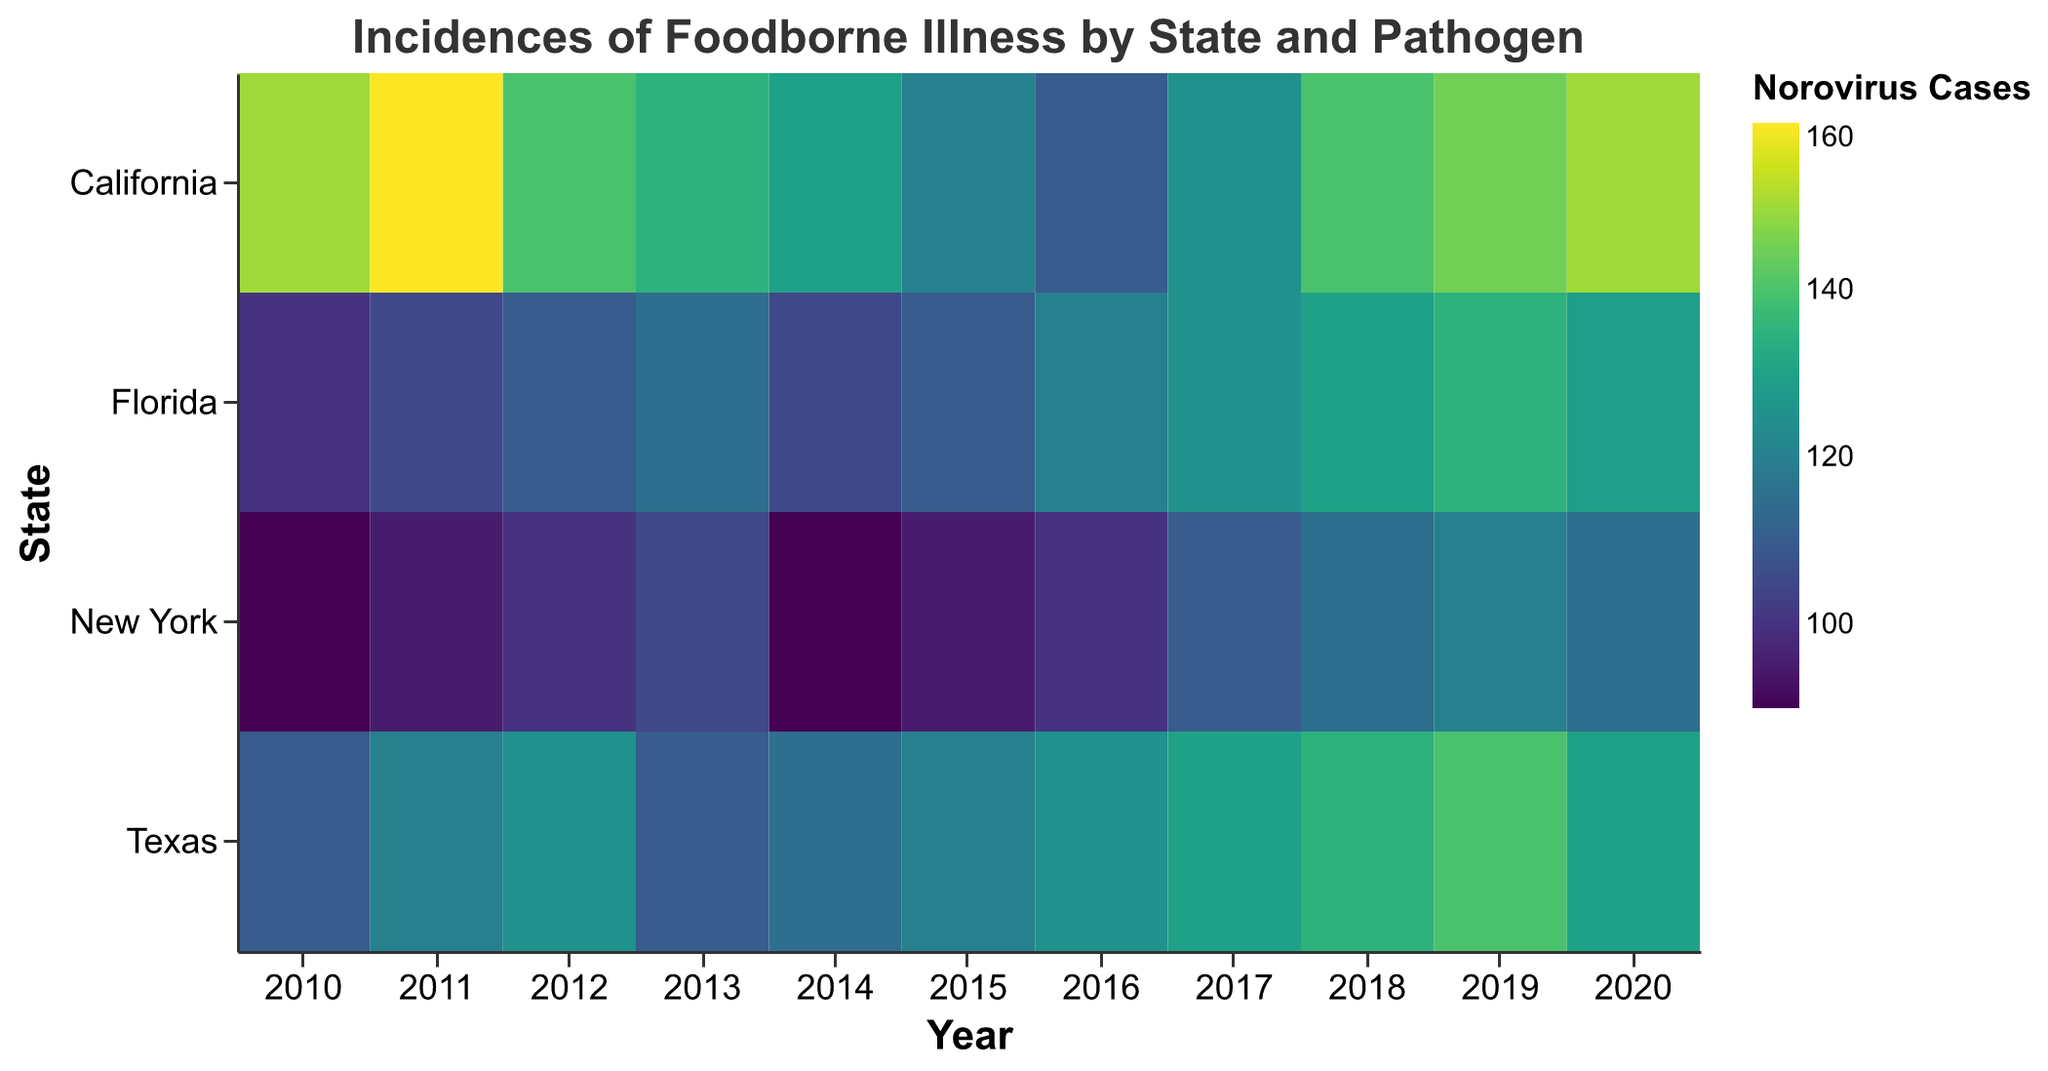What is the title of the heatmap? The title is typically found at the top of the heatmap and provides a summary of what the figure represents. In this case, the title is directly stated in the data provided.
Answer: Incidences of Foodborne Illness by State and Pathogen What is the highest number of Norovirus cases in Texas between 2010 and 2020? To answer this, scan the Texas row for the highest value in the Norovirus column from 2010 to 2020.
Answer: 140 Which state had the highest instances of Salmonella in 2011? To find this, compare the Salmonella values for all states in the year 2011 to determine which state has the highest value. In 2011, California has 140 cases, Texas 100, Florida 85, and New York 80. Therefore, California had the highest instances.
Answer: California How did the number of Campylobacter cases in New York change from 2010 to 2020? Check the Campylobacter values for New York in 2010 and 2020. In 2010, the value is 60, and in 2020 it is 64. The change is calculated by subtracting the initial value from the final value, which is 64 - 60.
Answer: Increased by 4 Between California and Florida in 2020, which state had more cases of E. coli, and by how much? Compare the E. coli values for California and Florida in 2020. California has 33 cases, and Florida has 28 cases. The difference is 33 - 28.
Answer: California, by 5 cases What is the average number of Norovirus cases in California over the decade? To determine this, add up the Norovirus cases in California for each year from 2010 to 2020 and then divide by the number of years (11). The total is 150 + 160 + 140 + 135 + 130 + 120 + 110 + 125 + 140 + 145 + 150, which sums to 1505. The average is 1505 / 11.
Answer: 136.82 Which state showed the most significant reduction in Salmonella cases between 2010 and 2020? Calculate the difference in Salmonella cases from 2010 to 2020 for each state and determine which state has the largest negative difference. By checking the values: California (120 to 105, difference -15), Texas (90 to 100, difference +10), Florida (80 to 102, difference +22), New York (70 to 87, difference +17).
Answer: California What was the trend in Norovirus cases in Florida from 2010 to 2020? Observe the Norovirus values for Florida each year and determine the pattern or trend. The values are: 100, 105, 110, 115, 105, 110, 120, 125, 130, 135, 129. The overall trend is increasing despite slight decreases in certain years.
Answer: Increasing trend If you were to sum the cases of E. coli for New York across all years, what would be the total? Add the E. coli cases for New York for each year from 2010 to 2020. The total is 15 + 18 + 20 + 22 + 25 + 28 + 30 + 32 + 27 + 20 + 23, which equals 260.
Answer: 260 